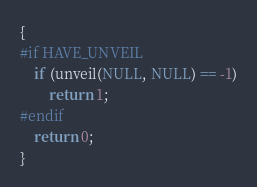<code> <loc_0><loc_0><loc_500><loc_500><_C_>{
#if HAVE_UNVEIL
	if (unveil(NULL, NULL) == -1)
		return 1;
#endif
	return 0;
}
</code> 